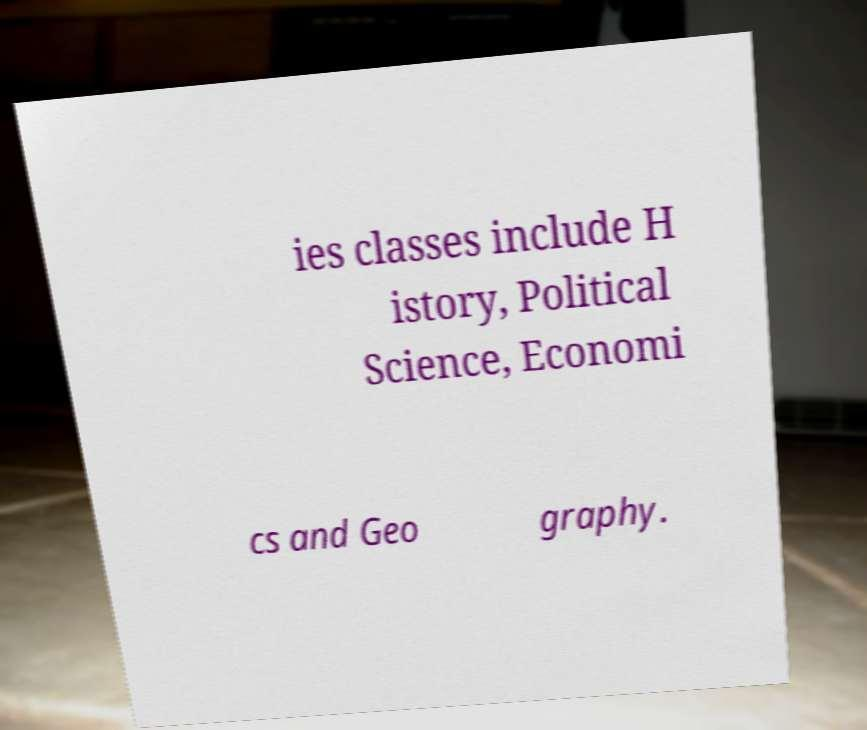For documentation purposes, I need the text within this image transcribed. Could you provide that? ies classes include H istory, Political Science, Economi cs and Geo graphy. 